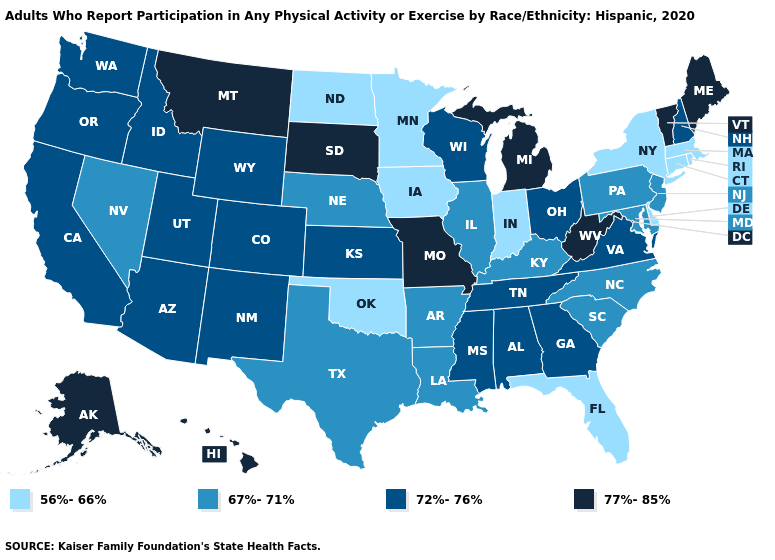Does Alaska have the lowest value in the USA?
Quick response, please. No. Which states have the highest value in the USA?
Be succinct. Alaska, Hawaii, Maine, Michigan, Missouri, Montana, South Dakota, Vermont, West Virginia. Which states have the highest value in the USA?
Keep it brief. Alaska, Hawaii, Maine, Michigan, Missouri, Montana, South Dakota, Vermont, West Virginia. Name the states that have a value in the range 56%-66%?
Keep it brief. Connecticut, Delaware, Florida, Indiana, Iowa, Massachusetts, Minnesota, New York, North Dakota, Oklahoma, Rhode Island. What is the lowest value in the Northeast?
Answer briefly. 56%-66%. Does Missouri have a higher value than North Carolina?
Short answer required. Yes. Among the states that border Virginia , does West Virginia have the lowest value?
Quick response, please. No. What is the lowest value in states that border Indiana?
Be succinct. 67%-71%. Does South Carolina have the highest value in the USA?
Answer briefly. No. Does Minnesota have the lowest value in the MidWest?
Concise answer only. Yes. Does Georgia have a higher value than Wyoming?
Quick response, please. No. Is the legend a continuous bar?
Quick response, please. No. Name the states that have a value in the range 77%-85%?
Quick response, please. Alaska, Hawaii, Maine, Michigan, Missouri, Montana, South Dakota, Vermont, West Virginia. How many symbols are there in the legend?
Answer briefly. 4. Name the states that have a value in the range 72%-76%?
Give a very brief answer. Alabama, Arizona, California, Colorado, Georgia, Idaho, Kansas, Mississippi, New Hampshire, New Mexico, Ohio, Oregon, Tennessee, Utah, Virginia, Washington, Wisconsin, Wyoming. 